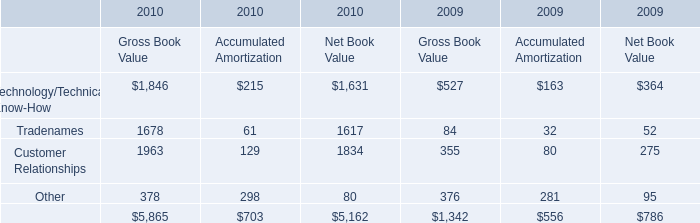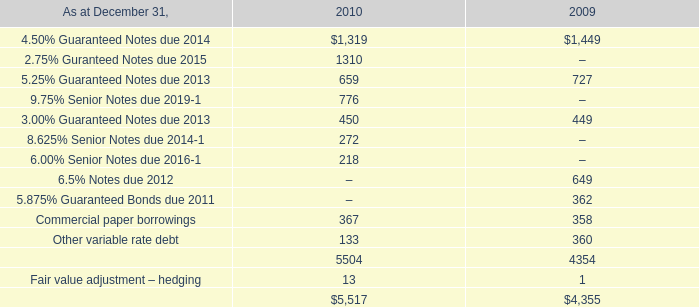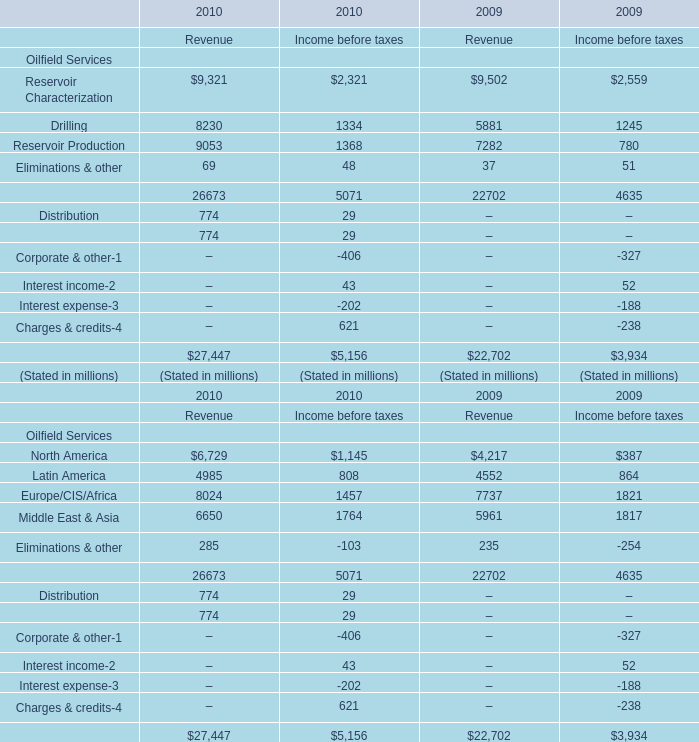What's the current growth rate of Latin America for revenue? (in %) 
Computations: ((4985 - 4552) / 4552)
Answer: 0.09512. 